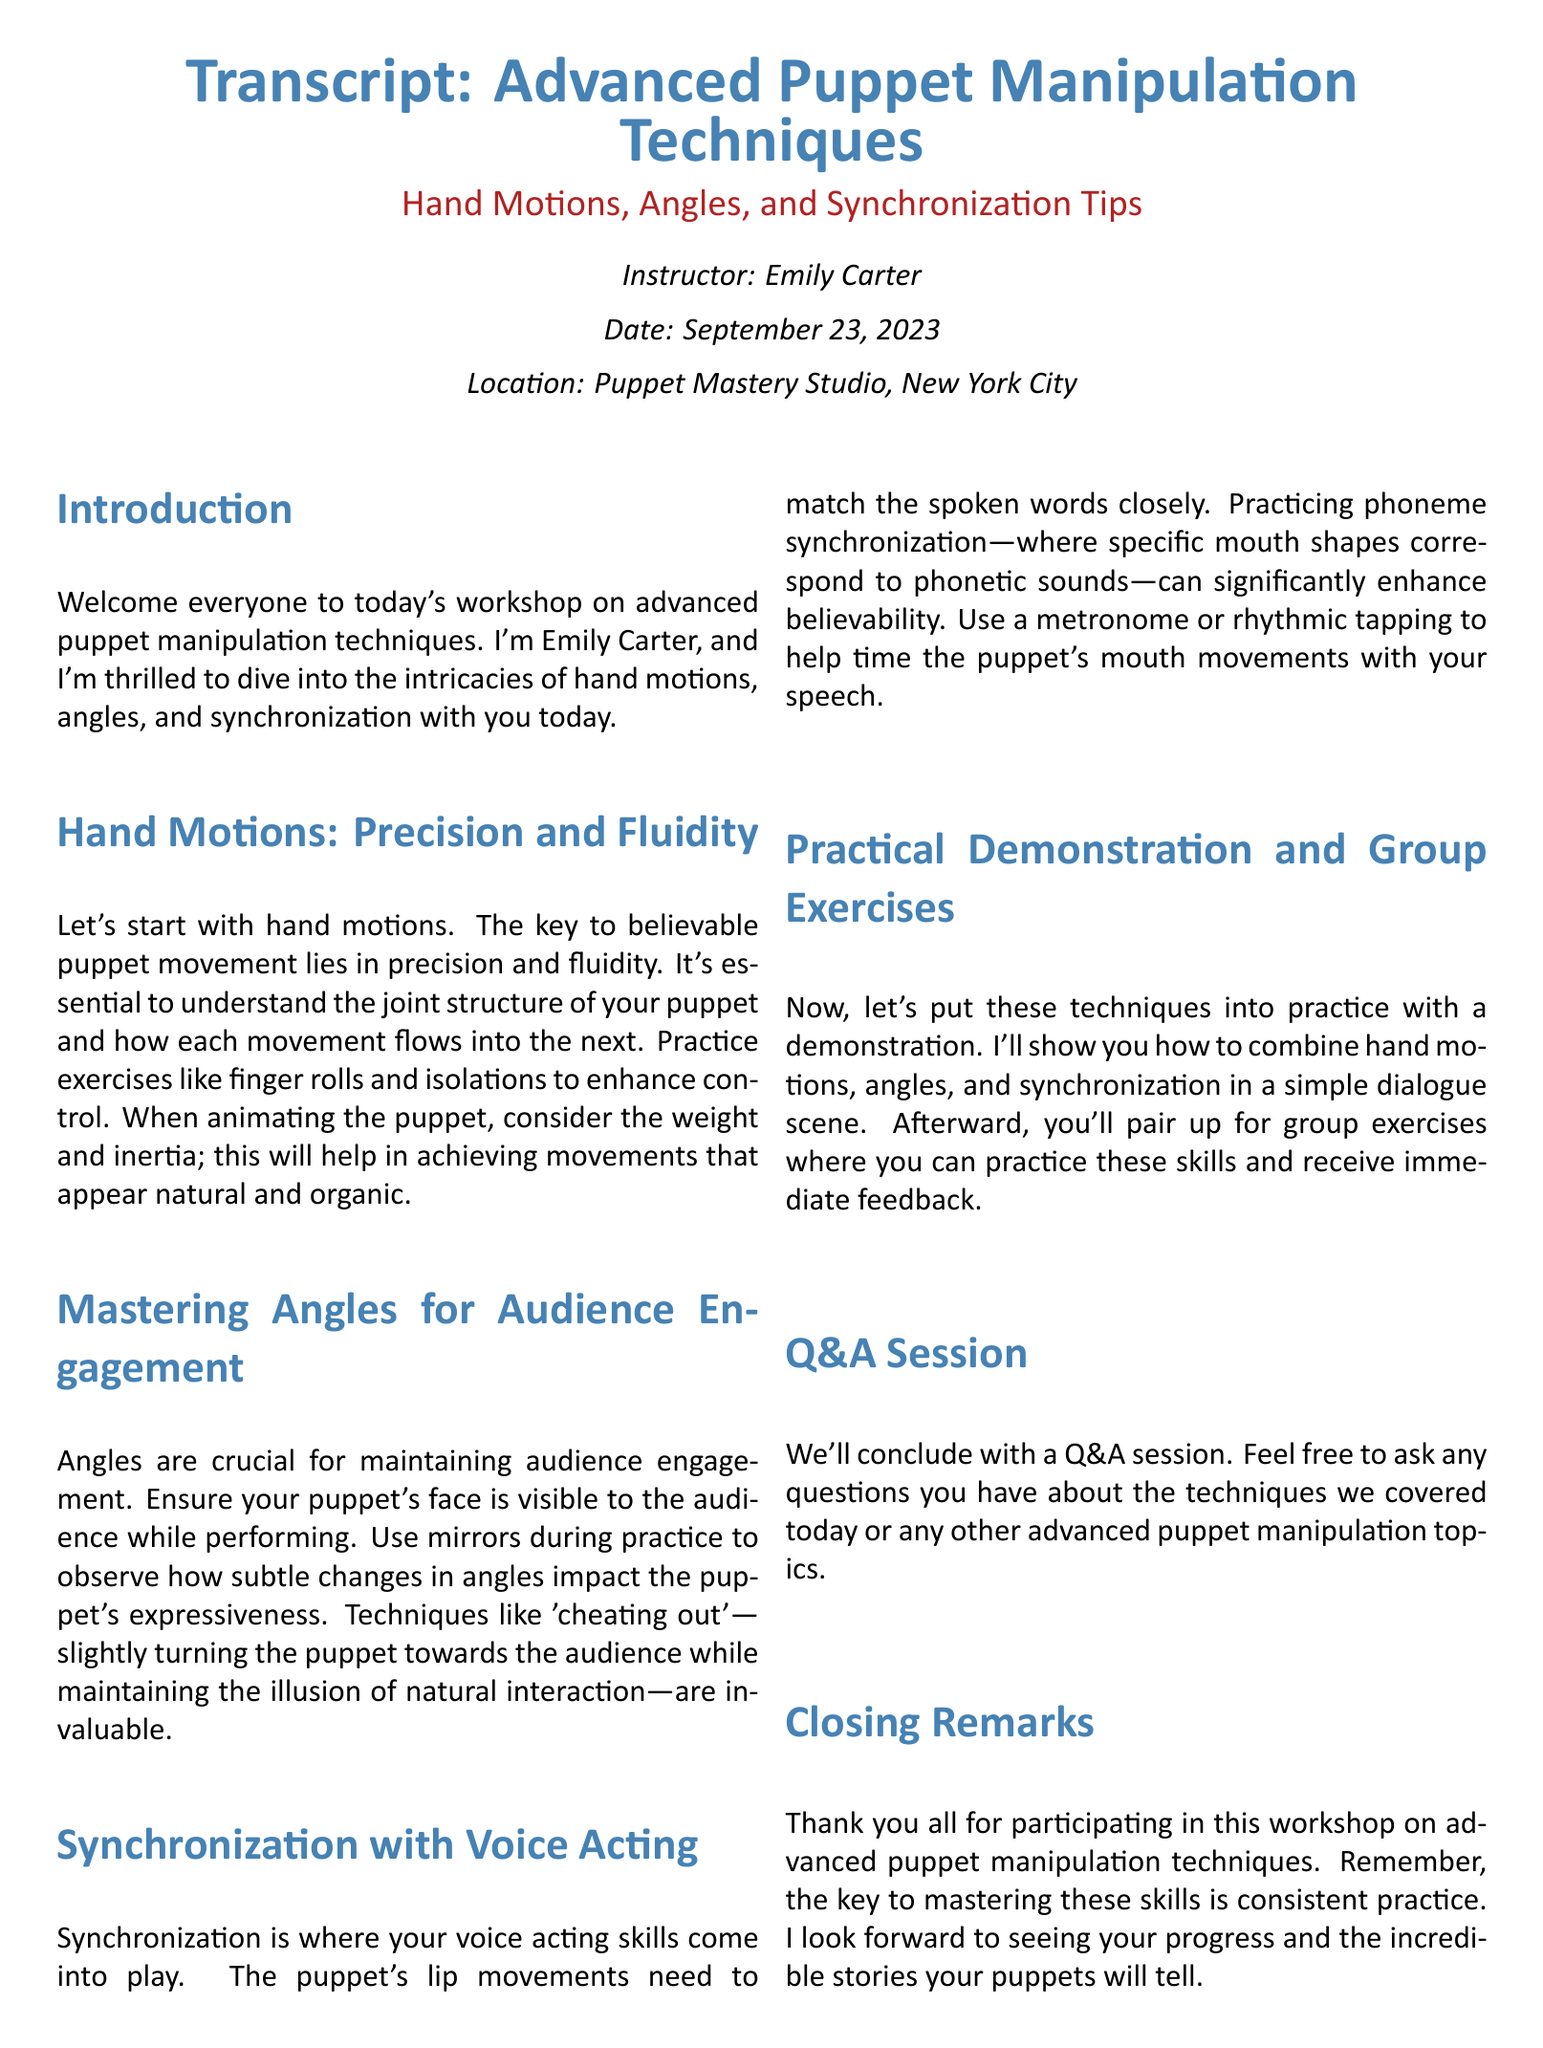What is the name of the instructor? The name of the instructor is mentioned in the document under the instructor section.
Answer: Emily Carter What date was the workshop held? The date is explicitly stated at the beginning of the document.
Answer: September 23, 2023 What is the main focus of the workshop? The main focus can be found in the title and introduction of the document.
Answer: Advanced puppet manipulation techniques What is emphasized for believable puppet movement? This information is provided in the section discussing hand motions.
Answer: Precision and fluidity What technique helps with puppet's lip movements matching speech? This technique is detailed in the section on synchronization with voice acting.
Answer: Phoneme synchronization What should be used during practice to observe angles? This is suggested within the mastering angles section.
Answer: Mirrors How was the workshop concluded? The conclusion section provides insight into how the workshop ended.
Answer: Q&A session What is a key requirement for mastering the discussed skills? This requirement is highlighted in the closing remarks of the workshop.
Answer: Consistent practice 